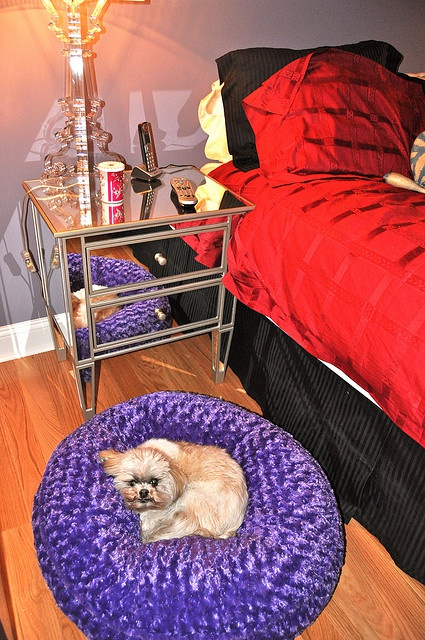Describe the objects in this image and their specific colors. I can see bed in salmon, red, black, brown, and maroon tones, dog in salmon, ivory, and tan tones, and remote in salmon, black, and brown tones in this image. 